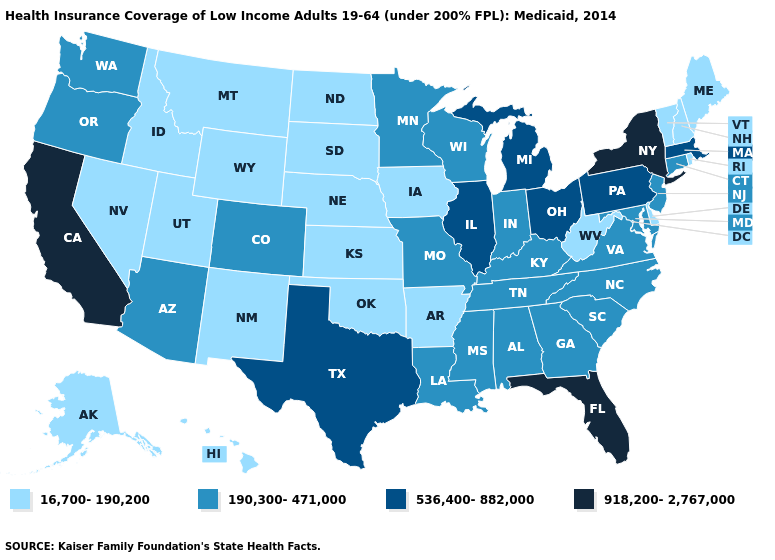Which states hav the highest value in the MidWest?
Write a very short answer. Illinois, Michigan, Ohio. Does New Hampshire have a lower value than Vermont?
Quick response, please. No. Which states have the highest value in the USA?
Concise answer only. California, Florida, New York. Name the states that have a value in the range 918,200-2,767,000?
Answer briefly. California, Florida, New York. How many symbols are there in the legend?
Write a very short answer. 4. Which states hav the highest value in the South?
Be succinct. Florida. What is the value of West Virginia?
Write a very short answer. 16,700-190,200. Which states have the highest value in the USA?
Concise answer only. California, Florida, New York. Name the states that have a value in the range 190,300-471,000?
Keep it brief. Alabama, Arizona, Colorado, Connecticut, Georgia, Indiana, Kentucky, Louisiana, Maryland, Minnesota, Mississippi, Missouri, New Jersey, North Carolina, Oregon, South Carolina, Tennessee, Virginia, Washington, Wisconsin. What is the value of West Virginia?
Give a very brief answer. 16,700-190,200. How many symbols are there in the legend?
Answer briefly. 4. Name the states that have a value in the range 536,400-882,000?
Be succinct. Illinois, Massachusetts, Michigan, Ohio, Pennsylvania, Texas. Among the states that border Mississippi , does Arkansas have the lowest value?
Give a very brief answer. Yes. Name the states that have a value in the range 190,300-471,000?
Quick response, please. Alabama, Arizona, Colorado, Connecticut, Georgia, Indiana, Kentucky, Louisiana, Maryland, Minnesota, Mississippi, Missouri, New Jersey, North Carolina, Oregon, South Carolina, Tennessee, Virginia, Washington, Wisconsin. What is the highest value in the Northeast ?
Be succinct. 918,200-2,767,000. 